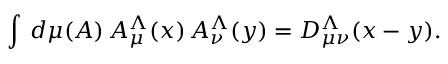<formula> <loc_0><loc_0><loc_500><loc_500>\int \, d \mu ( A ) \, A _ { \mu } ^ { \Lambda } ( x ) \, A _ { \nu } ^ { \Lambda } ( y ) = D _ { \mu \nu } ^ { \Lambda } ( x - y ) .</formula> 